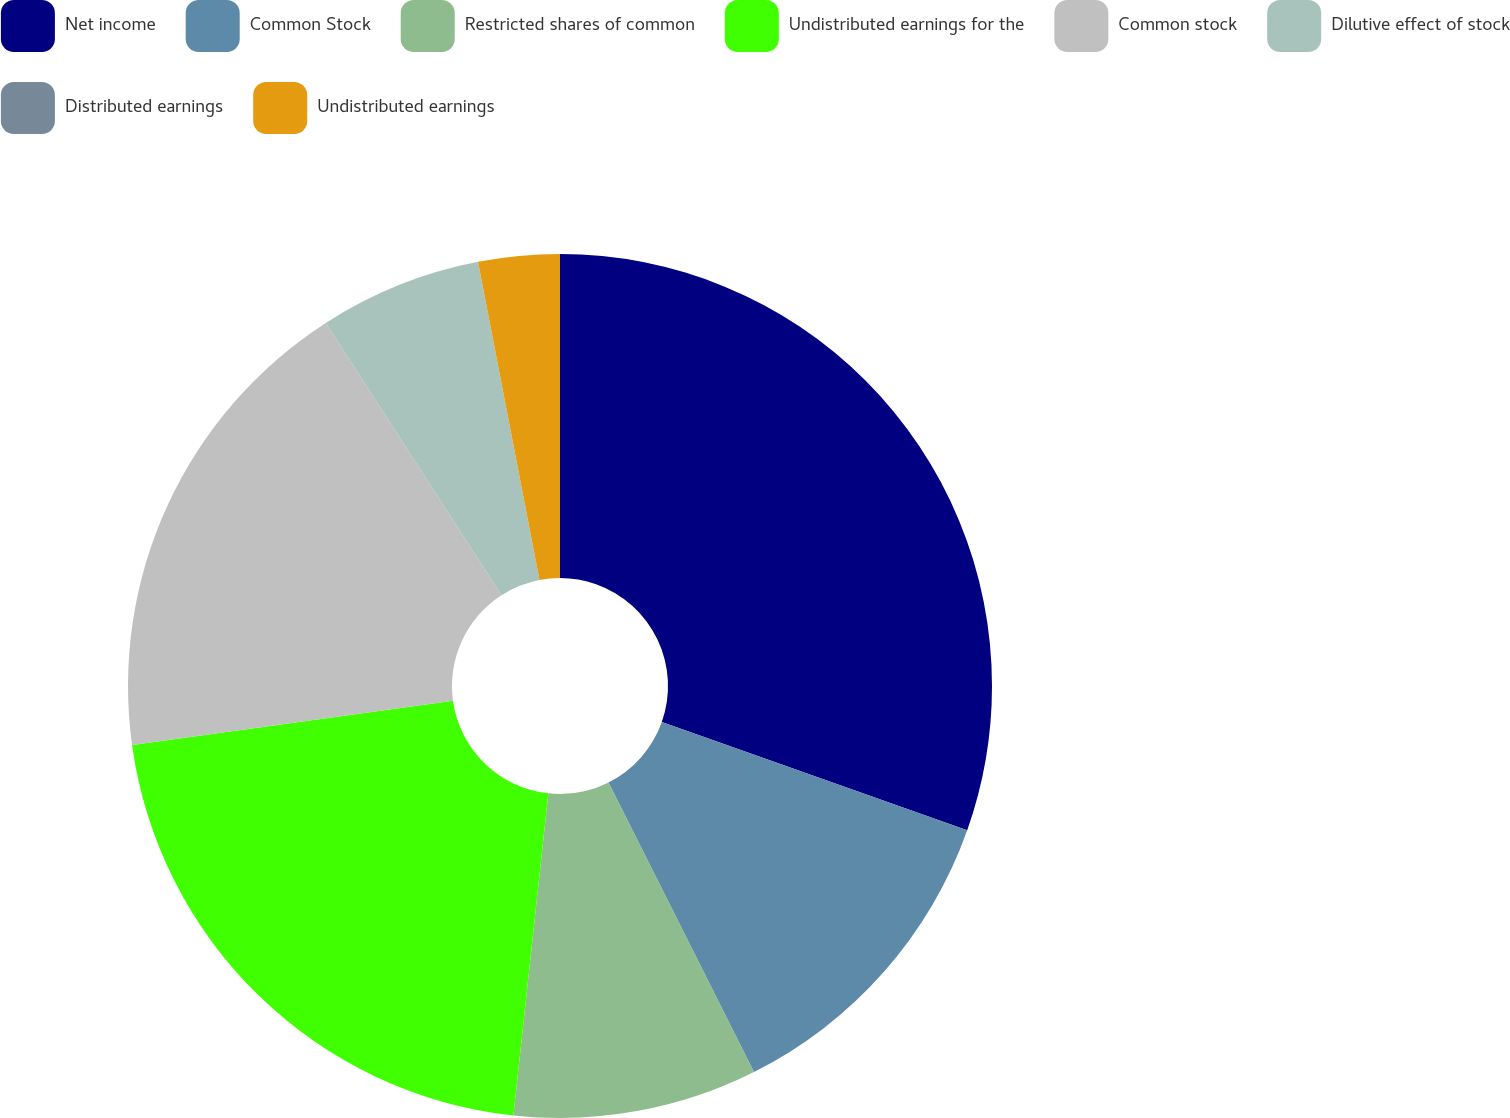<chart> <loc_0><loc_0><loc_500><loc_500><pie_chart><fcel>Net income<fcel>Common Stock<fcel>Restricted shares of common<fcel>Undistributed earnings for the<fcel>Common stock<fcel>Dilutive effect of stock<fcel>Distributed earnings<fcel>Undistributed earnings<nl><fcel>30.42%<fcel>12.17%<fcel>9.13%<fcel>21.1%<fcel>18.06%<fcel>6.08%<fcel>0.0%<fcel>3.04%<nl></chart> 